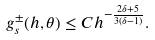<formula> <loc_0><loc_0><loc_500><loc_500>g _ { s } ^ { \pm } ( h , \theta ) \leq C h ^ { - \frac { 2 \delta + 5 } { 3 ( \delta - 1 ) } } .</formula> 